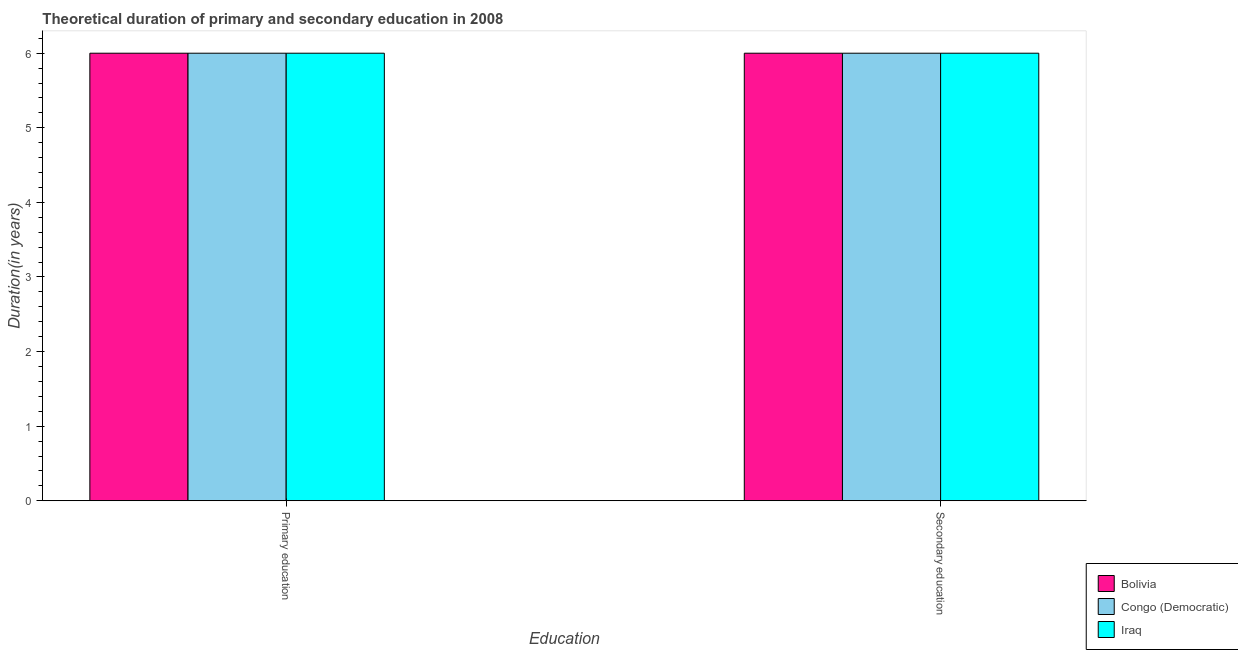Are the number of bars per tick equal to the number of legend labels?
Keep it short and to the point. Yes. Are the number of bars on each tick of the X-axis equal?
Offer a terse response. Yes. How many bars are there on the 2nd tick from the right?
Your answer should be compact. 3. Across all countries, what is the minimum duration of primary education?
Your answer should be very brief. 6. What is the total duration of secondary education in the graph?
Offer a very short reply. 18. What is the average duration of primary education per country?
Make the answer very short. 6. In how many countries, is the duration of primary education greater than 4.2 years?
Ensure brevity in your answer.  3. What is the ratio of the duration of secondary education in Bolivia to that in Congo (Democratic)?
Your answer should be very brief. 1. Is the duration of primary education in Congo (Democratic) less than that in Iraq?
Provide a short and direct response. No. What does the 3rd bar from the left in Primary education represents?
Keep it short and to the point. Iraq. What does the 2nd bar from the right in Secondary education represents?
Provide a succinct answer. Congo (Democratic). How many bars are there?
Keep it short and to the point. 6. What is the difference between two consecutive major ticks on the Y-axis?
Offer a very short reply. 1. Are the values on the major ticks of Y-axis written in scientific E-notation?
Give a very brief answer. No. Does the graph contain any zero values?
Give a very brief answer. No. Where does the legend appear in the graph?
Offer a terse response. Bottom right. What is the title of the graph?
Keep it short and to the point. Theoretical duration of primary and secondary education in 2008. What is the label or title of the X-axis?
Your answer should be very brief. Education. What is the label or title of the Y-axis?
Your answer should be compact. Duration(in years). What is the Duration(in years) in Bolivia in Secondary education?
Provide a succinct answer. 6. Across all Education, what is the minimum Duration(in years) in Bolivia?
Keep it short and to the point. 6. Across all Education, what is the minimum Duration(in years) of Congo (Democratic)?
Give a very brief answer. 6. Across all Education, what is the minimum Duration(in years) of Iraq?
Offer a terse response. 6. What is the total Duration(in years) of Iraq in the graph?
Provide a short and direct response. 12. What is the difference between the Duration(in years) of Congo (Democratic) in Primary education and that in Secondary education?
Provide a short and direct response. 0. What is the difference between the Duration(in years) in Iraq in Primary education and that in Secondary education?
Provide a short and direct response. 0. What is the difference between the Duration(in years) of Bolivia in Primary education and the Duration(in years) of Congo (Democratic) in Secondary education?
Keep it short and to the point. 0. What is the average Duration(in years) in Bolivia per Education?
Your response must be concise. 6. What is the average Duration(in years) of Congo (Democratic) per Education?
Your response must be concise. 6. What is the difference between the Duration(in years) in Bolivia and Duration(in years) in Congo (Democratic) in Primary education?
Make the answer very short. 0. What is the difference between the Duration(in years) of Bolivia and Duration(in years) of Iraq in Primary education?
Give a very brief answer. 0. What is the difference between the Duration(in years) in Congo (Democratic) and Duration(in years) in Iraq in Primary education?
Make the answer very short. 0. What is the difference between the Duration(in years) in Bolivia and Duration(in years) in Congo (Democratic) in Secondary education?
Your answer should be very brief. 0. What is the difference between the Duration(in years) in Bolivia and Duration(in years) in Iraq in Secondary education?
Your answer should be compact. 0. What is the ratio of the Duration(in years) of Bolivia in Primary education to that in Secondary education?
Provide a succinct answer. 1. What is the ratio of the Duration(in years) of Congo (Democratic) in Primary education to that in Secondary education?
Provide a succinct answer. 1. What is the ratio of the Duration(in years) in Iraq in Primary education to that in Secondary education?
Your answer should be very brief. 1. What is the difference between the highest and the second highest Duration(in years) in Bolivia?
Keep it short and to the point. 0. What is the difference between the highest and the second highest Duration(in years) of Iraq?
Keep it short and to the point. 0. What is the difference between the highest and the lowest Duration(in years) of Bolivia?
Give a very brief answer. 0. What is the difference between the highest and the lowest Duration(in years) of Iraq?
Offer a very short reply. 0. 